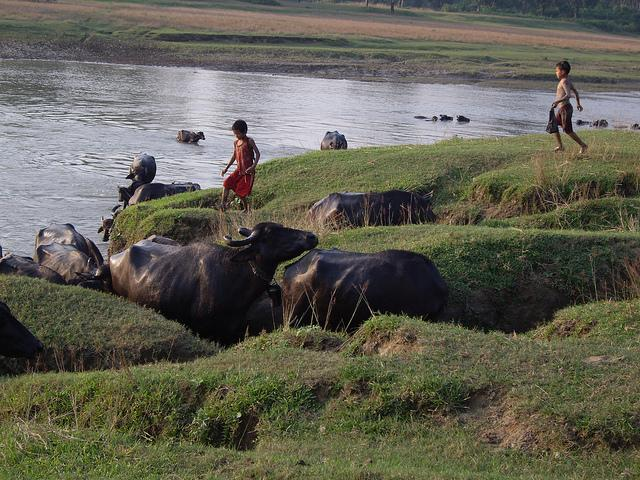How many children are running onto the cape with the water cows? Please explain your reasoning. two. There are two children running onto the cape with the large animals. 